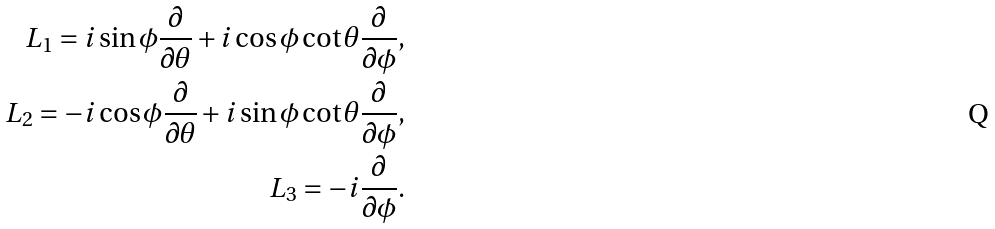<formula> <loc_0><loc_0><loc_500><loc_500>L _ { 1 } = i \sin \phi \frac { \partial } { \partial \theta } + i \cos \phi \cot \theta \frac { \partial } { \partial \phi } , \\ L _ { 2 } = - i \cos \phi \frac { \partial } { \partial \theta } + i \sin \phi \cot \theta \frac { \partial } { \partial \phi } , \\ L _ { 3 } = - i \frac { \partial } { \partial \phi } .</formula> 